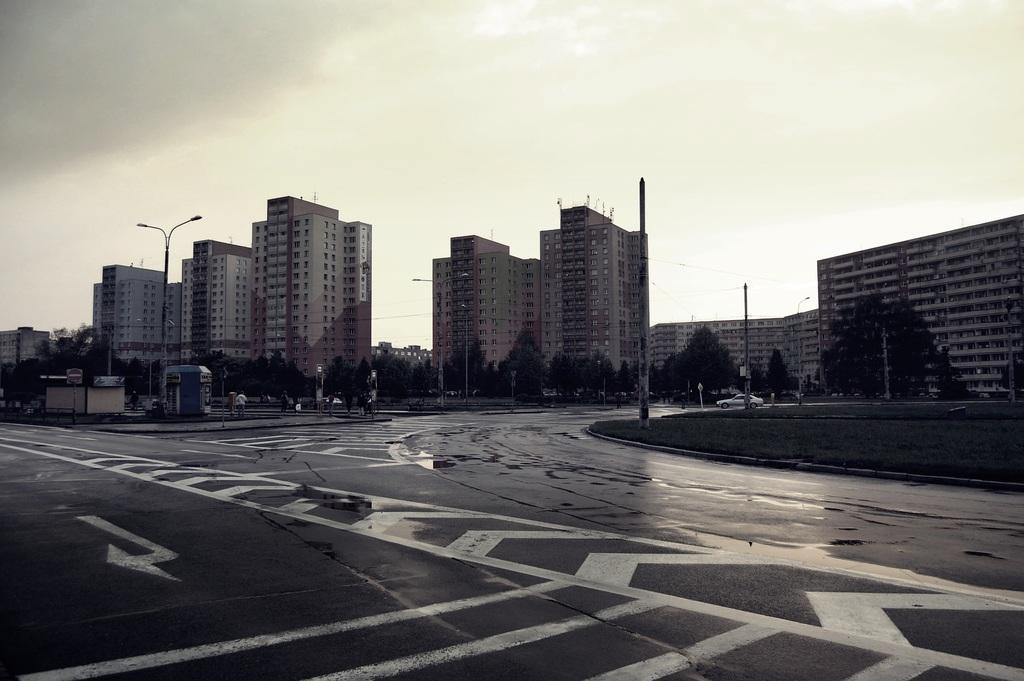Describe this image in one or two sentences. This is the road, there are big buildings in the long backs side. At the top it's a cloudy sky. 